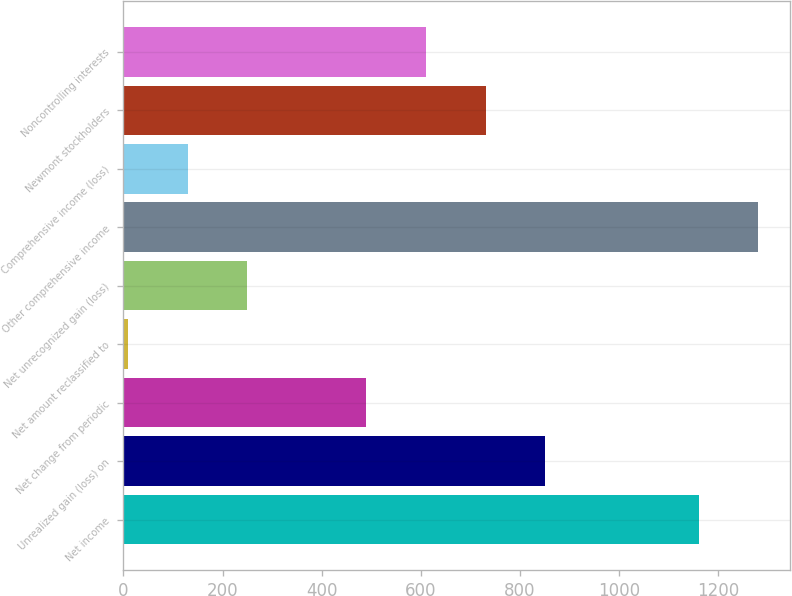Convert chart. <chart><loc_0><loc_0><loc_500><loc_500><bar_chart><fcel>Net income<fcel>Unrealized gain (loss) on<fcel>Net change from periodic<fcel>Net amount reclassified to<fcel>Net unrecognized gain (loss)<fcel>Other comprehensive income<fcel>Comprehensive income (loss)<fcel>Newmont stockholders<fcel>Noncontrolling interests<nl><fcel>1160<fcel>851.1<fcel>490.2<fcel>9<fcel>249.6<fcel>1280.3<fcel>129.3<fcel>730.8<fcel>610.5<nl></chart> 